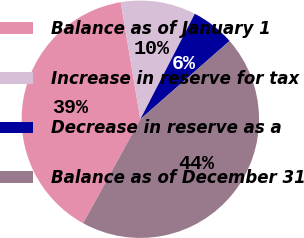<chart> <loc_0><loc_0><loc_500><loc_500><pie_chart><fcel>Balance as of January 1<fcel>Increase in reserve for tax<fcel>Decrease in reserve as a<fcel>Balance as of December 31<nl><fcel>39.35%<fcel>10.23%<fcel>5.95%<fcel>44.46%<nl></chart> 